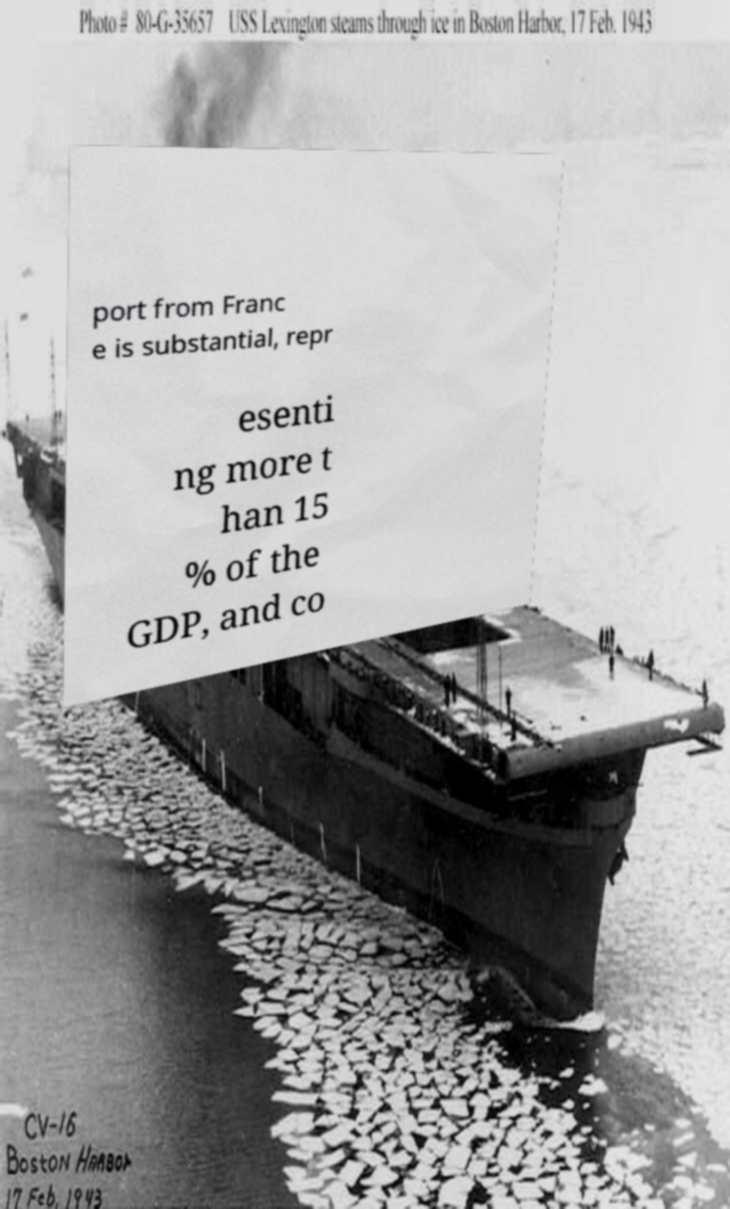Please identify and transcribe the text found in this image. port from Franc e is substantial, repr esenti ng more t han 15 % of the GDP, and co 